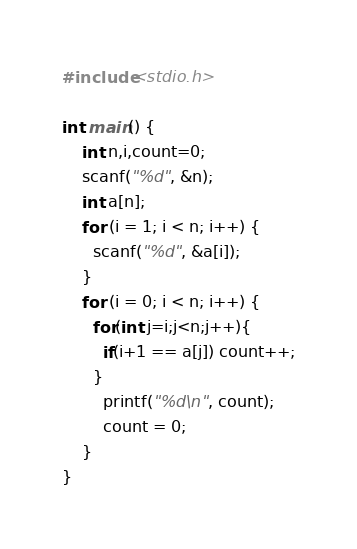<code> <loc_0><loc_0><loc_500><loc_500><_C_>#include<stdio.h>

int main() {
	int n,i,count=0;
	scanf("%d", &n);
	int a[n];
	for (i = 1; i < n; i++) {
      scanf("%d", &a[i]);
    }
	for (i = 0; i < n; i++) {
      for(int j=i;j<n;j++){
        if(i+1 == a[j]) count++;
      }
		printf("%d\n", count);
		count = 0;      
    }
}</code> 